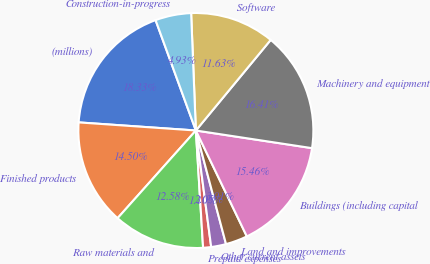Convert chart to OTSL. <chart><loc_0><loc_0><loc_500><loc_500><pie_chart><fcel>(millions)<fcel>Finished products<fcel>Raw materials and<fcel>Prepaid expenses<fcel>Other current assets<fcel>Land and improvements<fcel>Buildings (including capital<fcel>Machinery and equipment<fcel>Software<fcel>Construction-in-progress<nl><fcel>18.33%<fcel>14.5%<fcel>12.58%<fcel>1.1%<fcel>2.05%<fcel>3.01%<fcel>15.46%<fcel>16.41%<fcel>11.63%<fcel>4.93%<nl></chart> 